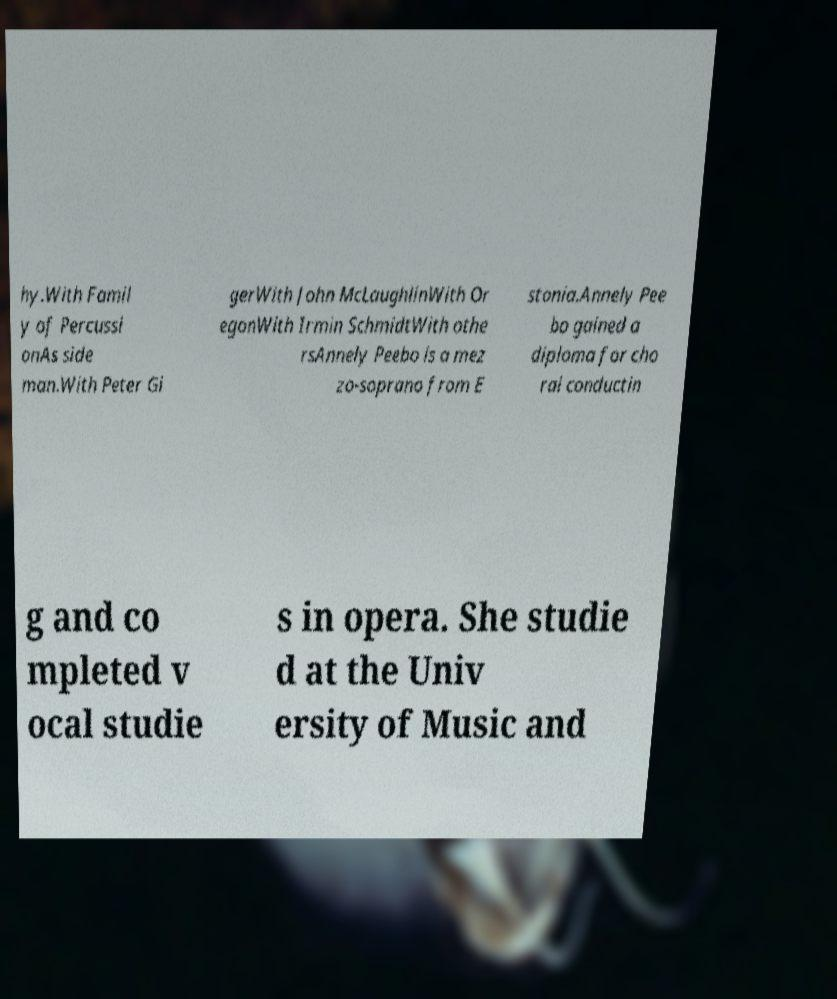Could you extract and type out the text from this image? hy.With Famil y of Percussi onAs side man.With Peter Gi gerWith John McLaughlinWith Or egonWith Irmin SchmidtWith othe rsAnnely Peebo is a mez zo-soprano from E stonia.Annely Pee bo gained a diploma for cho ral conductin g and co mpleted v ocal studie s in opera. She studie d at the Univ ersity of Music and 